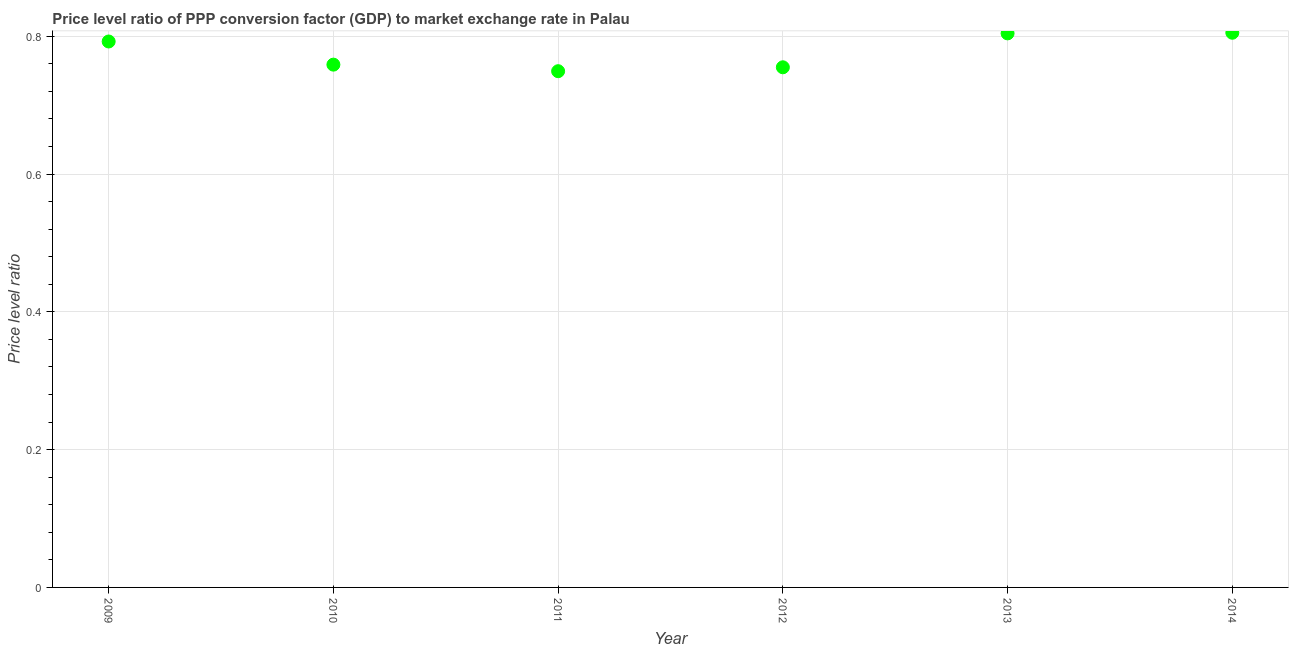What is the price level ratio in 2013?
Make the answer very short. 0.8. Across all years, what is the maximum price level ratio?
Your answer should be very brief. 0.81. Across all years, what is the minimum price level ratio?
Your answer should be compact. 0.75. In which year was the price level ratio minimum?
Ensure brevity in your answer.  2011. What is the sum of the price level ratio?
Your answer should be compact. 4.66. What is the difference between the price level ratio in 2010 and 2011?
Provide a short and direct response. 0.01. What is the average price level ratio per year?
Keep it short and to the point. 0.78. What is the median price level ratio?
Make the answer very short. 0.78. In how many years, is the price level ratio greater than 0.7200000000000001 ?
Provide a succinct answer. 6. Do a majority of the years between 2012 and 2010 (inclusive) have price level ratio greater than 0.56 ?
Provide a succinct answer. No. What is the ratio of the price level ratio in 2011 to that in 2013?
Give a very brief answer. 0.93. What is the difference between the highest and the second highest price level ratio?
Keep it short and to the point. 0. What is the difference between the highest and the lowest price level ratio?
Give a very brief answer. 0.06. What is the difference between two consecutive major ticks on the Y-axis?
Offer a very short reply. 0.2. Are the values on the major ticks of Y-axis written in scientific E-notation?
Give a very brief answer. No. What is the title of the graph?
Make the answer very short. Price level ratio of PPP conversion factor (GDP) to market exchange rate in Palau. What is the label or title of the X-axis?
Offer a very short reply. Year. What is the label or title of the Y-axis?
Ensure brevity in your answer.  Price level ratio. What is the Price level ratio in 2009?
Make the answer very short. 0.79. What is the Price level ratio in 2010?
Your response must be concise. 0.76. What is the Price level ratio in 2011?
Provide a succinct answer. 0.75. What is the Price level ratio in 2012?
Provide a short and direct response. 0.75. What is the Price level ratio in 2013?
Provide a succinct answer. 0.8. What is the Price level ratio in 2014?
Provide a succinct answer. 0.81. What is the difference between the Price level ratio in 2009 and 2010?
Your answer should be compact. 0.03. What is the difference between the Price level ratio in 2009 and 2011?
Offer a terse response. 0.04. What is the difference between the Price level ratio in 2009 and 2012?
Keep it short and to the point. 0.04. What is the difference between the Price level ratio in 2009 and 2013?
Provide a short and direct response. -0.01. What is the difference between the Price level ratio in 2009 and 2014?
Offer a very short reply. -0.01. What is the difference between the Price level ratio in 2010 and 2011?
Provide a succinct answer. 0.01. What is the difference between the Price level ratio in 2010 and 2012?
Make the answer very short. 0. What is the difference between the Price level ratio in 2010 and 2013?
Ensure brevity in your answer.  -0.05. What is the difference between the Price level ratio in 2010 and 2014?
Give a very brief answer. -0.05. What is the difference between the Price level ratio in 2011 and 2012?
Offer a very short reply. -0.01. What is the difference between the Price level ratio in 2011 and 2013?
Offer a terse response. -0.05. What is the difference between the Price level ratio in 2011 and 2014?
Your response must be concise. -0.06. What is the difference between the Price level ratio in 2012 and 2013?
Give a very brief answer. -0.05. What is the difference between the Price level ratio in 2012 and 2014?
Provide a short and direct response. -0.05. What is the difference between the Price level ratio in 2013 and 2014?
Offer a very short reply. -0. What is the ratio of the Price level ratio in 2009 to that in 2010?
Provide a short and direct response. 1.04. What is the ratio of the Price level ratio in 2009 to that in 2011?
Your answer should be very brief. 1.06. What is the ratio of the Price level ratio in 2009 to that in 2013?
Your answer should be compact. 0.98. What is the ratio of the Price level ratio in 2009 to that in 2014?
Provide a succinct answer. 0.98. What is the ratio of the Price level ratio in 2010 to that in 2011?
Offer a very short reply. 1.01. What is the ratio of the Price level ratio in 2010 to that in 2013?
Your response must be concise. 0.94. What is the ratio of the Price level ratio in 2010 to that in 2014?
Your response must be concise. 0.94. What is the ratio of the Price level ratio in 2011 to that in 2012?
Your answer should be compact. 0.99. What is the ratio of the Price level ratio in 2011 to that in 2013?
Keep it short and to the point. 0.93. What is the ratio of the Price level ratio in 2011 to that in 2014?
Your answer should be compact. 0.93. What is the ratio of the Price level ratio in 2012 to that in 2013?
Make the answer very short. 0.94. What is the ratio of the Price level ratio in 2012 to that in 2014?
Your answer should be compact. 0.94. What is the ratio of the Price level ratio in 2013 to that in 2014?
Your response must be concise. 1. 